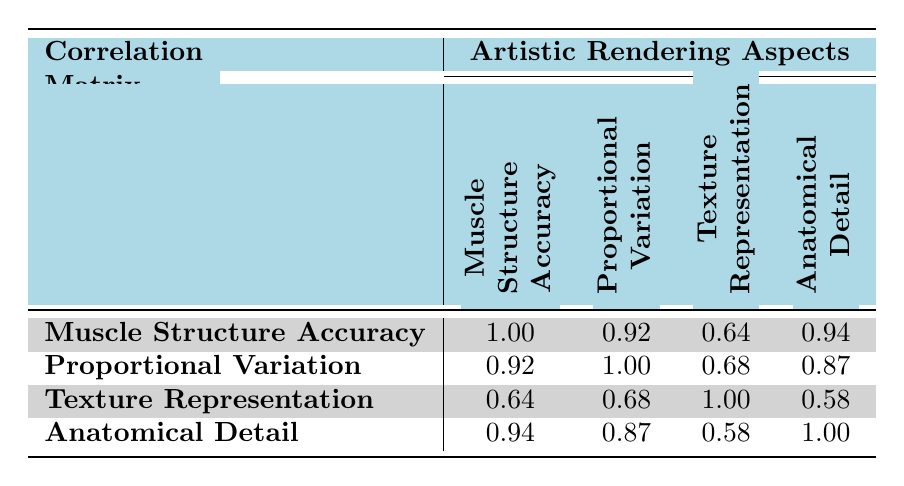What is the muscle structure accuracy for the Realistic Cat Anatomy? Looking at the corresponding row for Realistic Cat Anatomy, the muscle structure accuracy value is provided directly in the table. It is 0.76.
Answer: 0.76 Which artistic rendering has the highest anatomical detail? By comparing the anatomical detail values for each artistic rendering in the table, the highest value is found for the Playful Dog Illustration, which has a score of 0.86.
Answer: Playful Dog Illustration What is the average texture representation of all the artistic renderings? The texture representation scores are 0.70, 0.75, 0.68, 0.80, and 0.77. Adding these values together gives 0.70 + 0.75 + 0.68 + 0.80 + 0.77 = 3.70. Dividing by the number of renderings (5) gives an average of 3.70 / 5 = 0.74.
Answer: 0.74 Is there a correlation between muscle structure accuracy and proportional variation? Looking at the correlation table, the correlation value between muscle structure accuracy and proportional variation is 0.92, which is a strong positive correlation, indicating that as one increases, the other likely does as well.
Answer: Yes Which artistic rendering has the lowest proportional variation and what is its value? By evaluating the proportional variation scores for all the artistic renderings, the lowest value is associated with the Whimsical Elephant in Forest at 0.50.
Answer: Whimsical Elephant in Forest, 0.50 